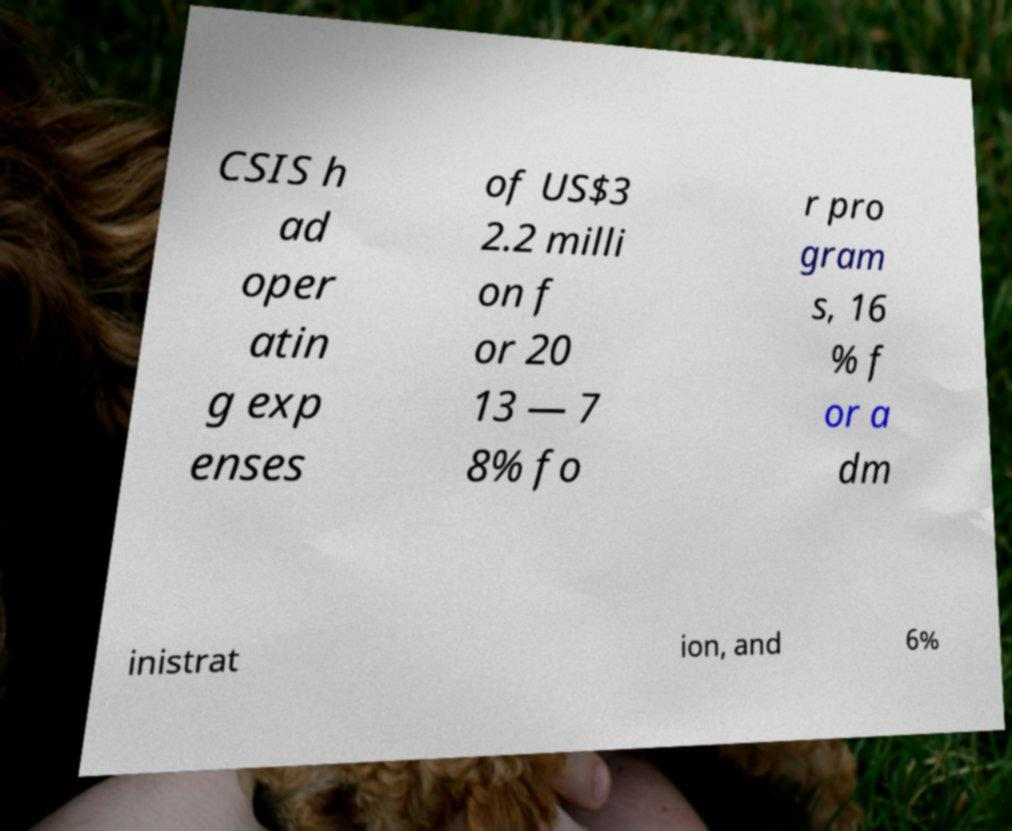What messages or text are displayed in this image? I need them in a readable, typed format. CSIS h ad oper atin g exp enses of US$3 2.2 milli on f or 20 13 — 7 8% fo r pro gram s, 16 % f or a dm inistrat ion, and 6% 